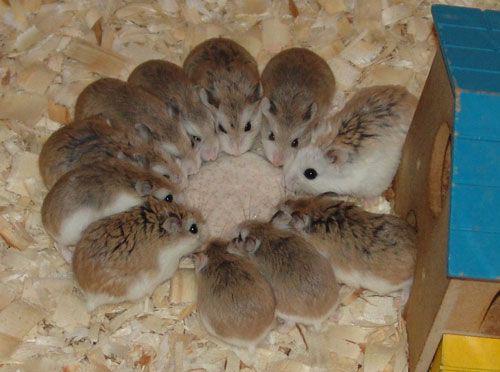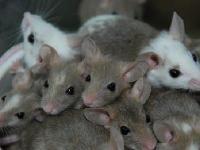The first image is the image on the left, the second image is the image on the right. Examine the images to the left and right. Is the description "There are no more than five tan hamsters in the image on the left." accurate? Answer yes or no. No. 